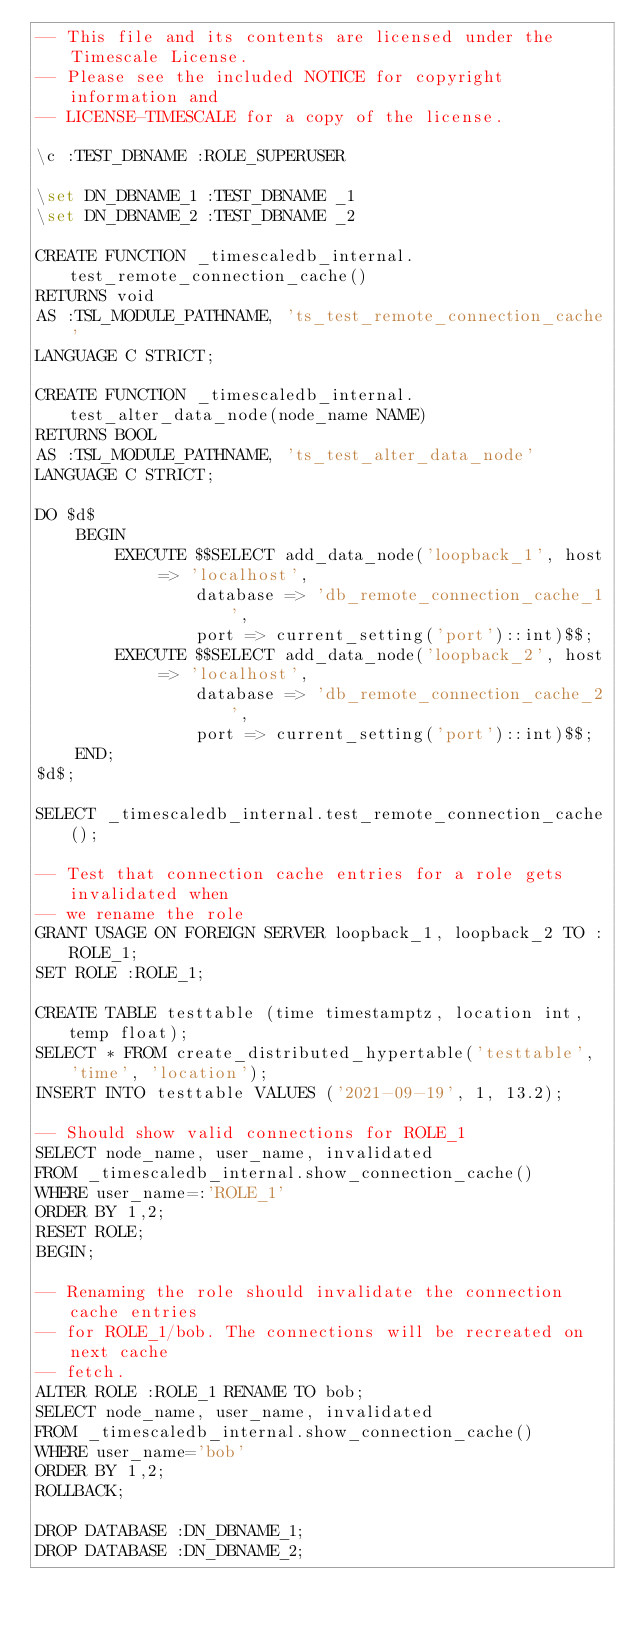<code> <loc_0><loc_0><loc_500><loc_500><_SQL_>-- This file and its contents are licensed under the Timescale License.
-- Please see the included NOTICE for copyright information and
-- LICENSE-TIMESCALE for a copy of the license.

\c :TEST_DBNAME :ROLE_SUPERUSER

\set DN_DBNAME_1 :TEST_DBNAME _1
\set DN_DBNAME_2 :TEST_DBNAME _2

CREATE FUNCTION _timescaledb_internal.test_remote_connection_cache()
RETURNS void
AS :TSL_MODULE_PATHNAME, 'ts_test_remote_connection_cache'
LANGUAGE C STRICT;

CREATE FUNCTION _timescaledb_internal.test_alter_data_node(node_name NAME)
RETURNS BOOL
AS :TSL_MODULE_PATHNAME, 'ts_test_alter_data_node'
LANGUAGE C STRICT;

DO $d$
    BEGIN
        EXECUTE $$SELECT add_data_node('loopback_1', host => 'localhost',
                database => 'db_remote_connection_cache_1',
                port => current_setting('port')::int)$$;
        EXECUTE $$SELECT add_data_node('loopback_2', host => 'localhost',
                database => 'db_remote_connection_cache_2',
                port => current_setting('port')::int)$$;
    END;
$d$;

SELECT _timescaledb_internal.test_remote_connection_cache();

-- Test that connection cache entries for a role gets invalidated when
-- we rename the role
GRANT USAGE ON FOREIGN SERVER loopback_1, loopback_2 TO :ROLE_1;
SET ROLE :ROLE_1;

CREATE TABLE testtable (time timestamptz, location int, temp float);
SELECT * FROM create_distributed_hypertable('testtable', 'time', 'location');
INSERT INTO testtable VALUES ('2021-09-19', 1, 13.2);

-- Should show valid connections for ROLE_1
SELECT node_name, user_name, invalidated
FROM _timescaledb_internal.show_connection_cache()
WHERE user_name=:'ROLE_1'
ORDER BY 1,2;
RESET ROLE;
BEGIN;

-- Renaming the role should invalidate the connection cache entries
-- for ROLE_1/bob. The connections will be recreated on next cache
-- fetch.
ALTER ROLE :ROLE_1 RENAME TO bob;
SELECT node_name, user_name, invalidated
FROM _timescaledb_internal.show_connection_cache()
WHERE user_name='bob'
ORDER BY 1,2;
ROLLBACK;

DROP DATABASE :DN_DBNAME_1;
DROP DATABASE :DN_DBNAME_2;
</code> 